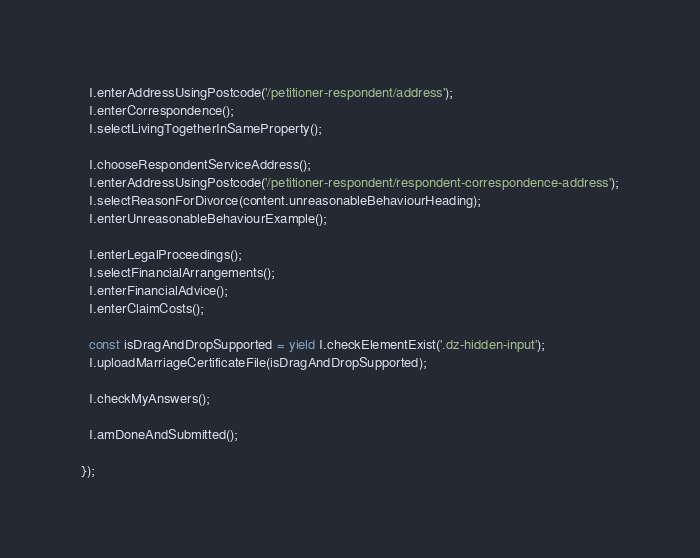<code> <loc_0><loc_0><loc_500><loc_500><_JavaScript_>  I.enterAddressUsingPostcode('/petitioner-respondent/address');
  I.enterCorrespondence();
  I.selectLivingTogetherInSameProperty();

  I.chooseRespondentServiceAddress();
  I.enterAddressUsingPostcode('/petitioner-respondent/respondent-correspondence-address');
  I.selectReasonForDivorce(content.unreasonableBehaviourHeading);
  I.enterUnreasonableBehaviourExample();

  I.enterLegalProceedings();
  I.selectFinancialArrangements();
  I.enterFinancialAdvice();
  I.enterClaimCosts();

  const isDragAndDropSupported = yield I.checkElementExist('.dz-hidden-input');
  I.uploadMarriageCertificateFile(isDragAndDropSupported);

  I.checkMyAnswers();

  I.amDoneAndSubmitted();

});</code> 